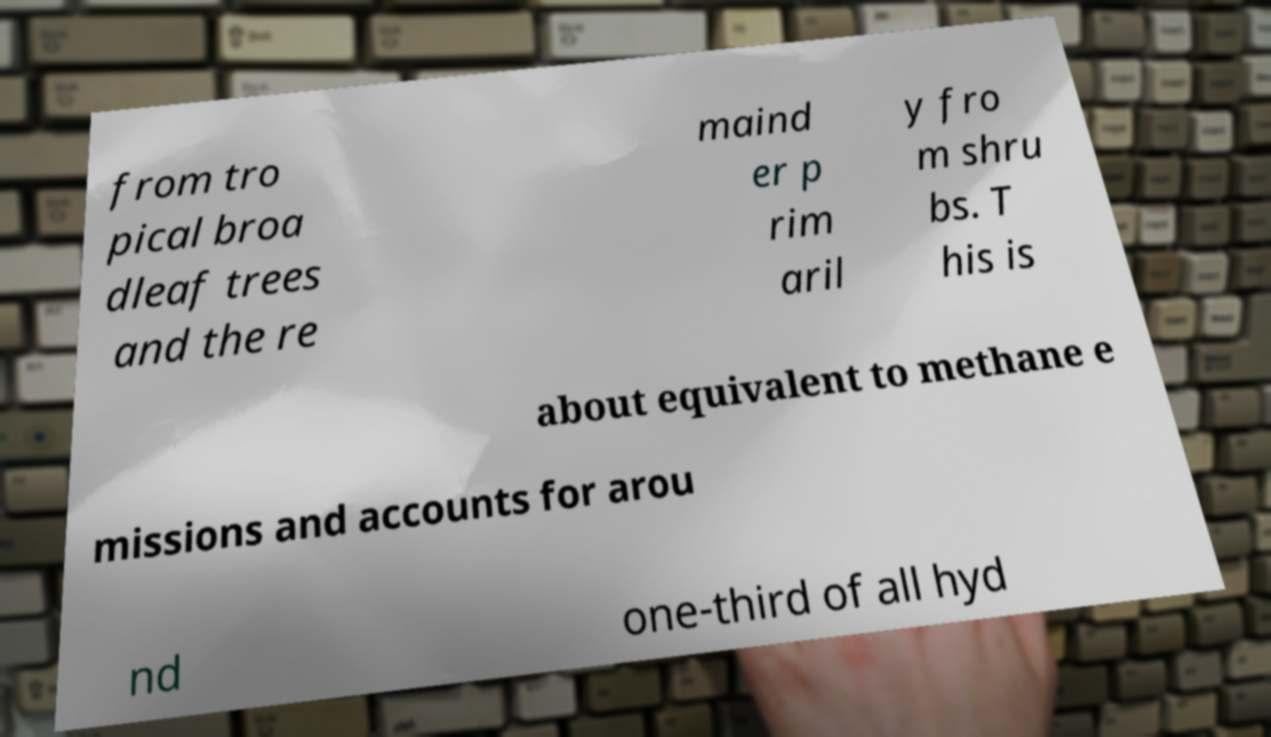For documentation purposes, I need the text within this image transcribed. Could you provide that? from tro pical broa dleaf trees and the re maind er p rim aril y fro m shru bs. T his is about equivalent to methane e missions and accounts for arou nd one-third of all hyd 